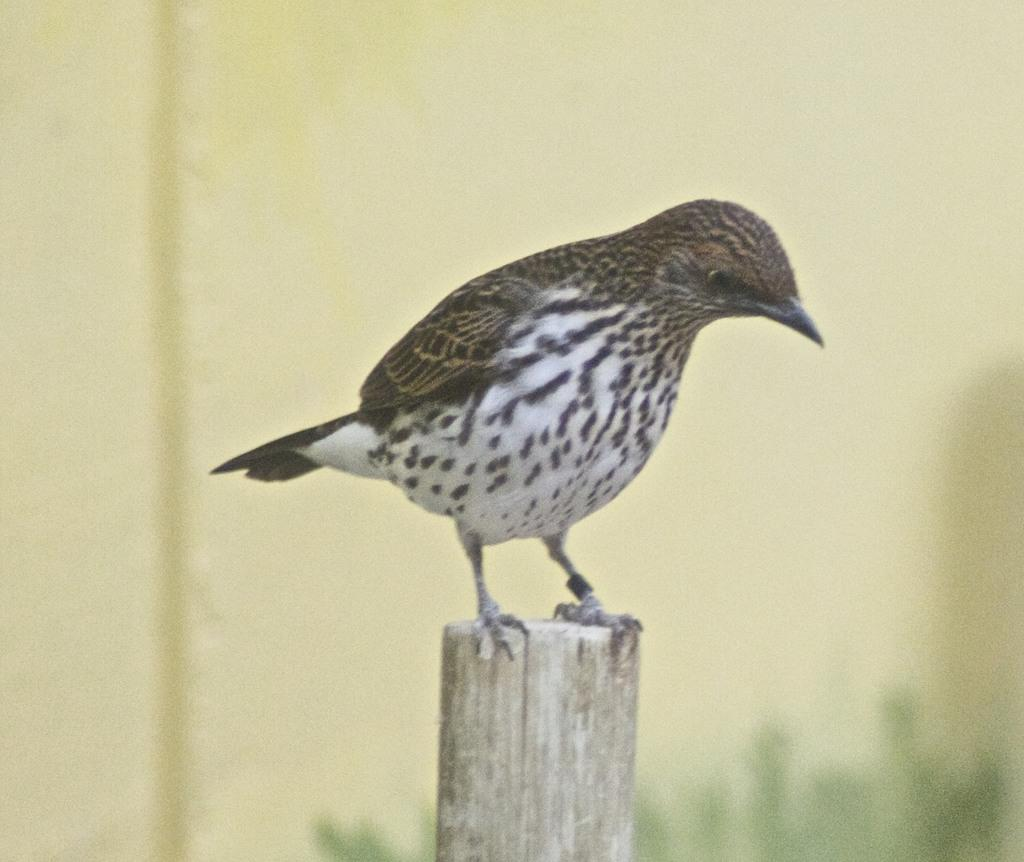What type of animal can be seen in the image? There is a bird in the image. Where is the bird located in the image? The bird is sitting on a bamboo pole. What is the name of the bird in the image? The provided facts do not mention the name of the bird, so we cannot determine its name from the image. 